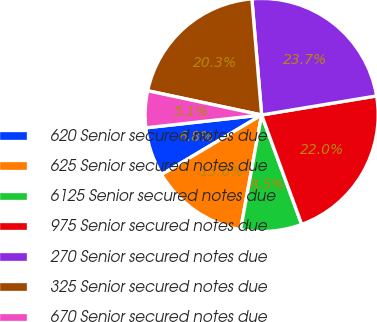Convert chart. <chart><loc_0><loc_0><loc_500><loc_500><pie_chart><fcel>620 Senior secured notes due<fcel>625 Senior secured notes due<fcel>6125 Senior secured notes due<fcel>975 Senior secured notes due<fcel>270 Senior secured notes due<fcel>325 Senior secured notes due<fcel>670 Senior secured notes due<nl><fcel>6.79%<fcel>13.56%<fcel>8.48%<fcel>22.03%<fcel>23.72%<fcel>20.33%<fcel>5.09%<nl></chart> 